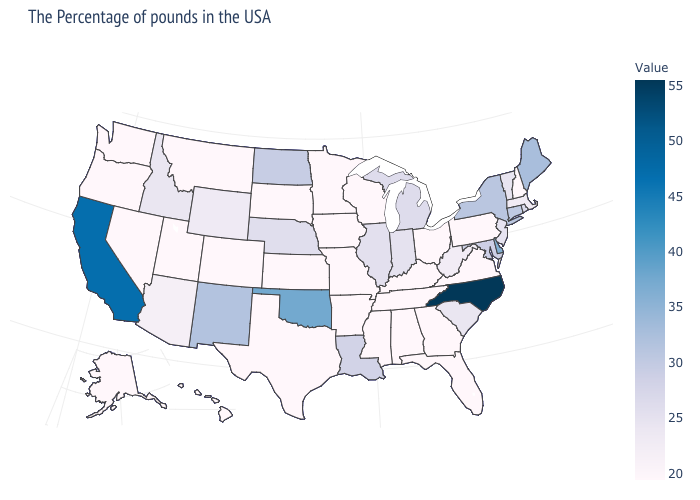Does New York have a higher value than North Carolina?
Be succinct. No. Among the states that border Texas , which have the highest value?
Write a very short answer. Oklahoma. Does South Dakota have the lowest value in the USA?
Keep it brief. Yes. Among the states that border Mississippi , does Tennessee have the highest value?
Short answer required. No. Does Kentucky have a lower value than Illinois?
Concise answer only. Yes. Is the legend a continuous bar?
Write a very short answer. Yes. 